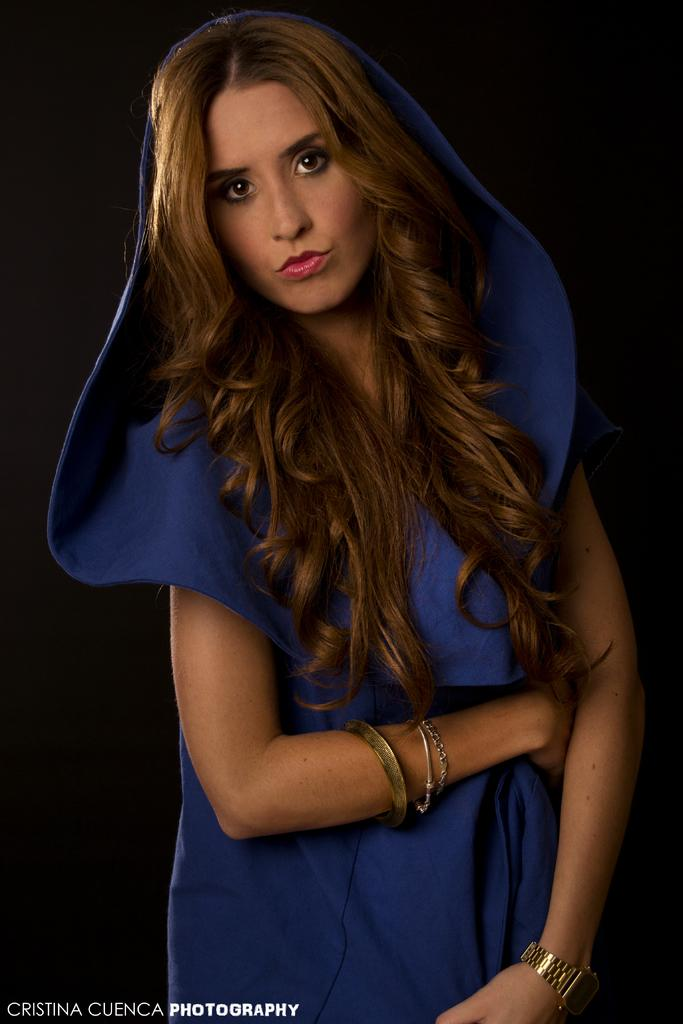Who is the main subject in the image? There is a woman in the image. What is the woman wearing? The woman is wearing a black dress. What can be seen in the background of the image? The background of the image is dark. What type of club does the woman belong to in the image? There is no indication in the image that the woman belongs to any club. What religious symbol can be seen in the image? There are no religious symbols present in the image. 